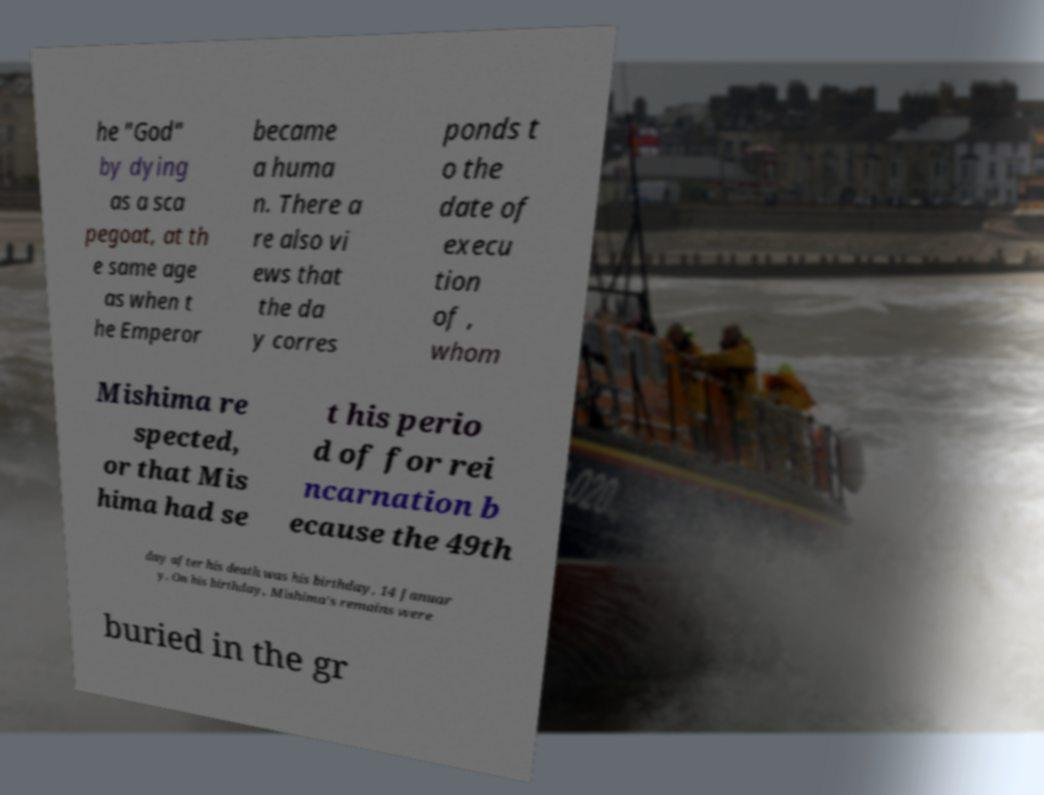There's text embedded in this image that I need extracted. Can you transcribe it verbatim? he "God" by dying as a sca pegoat, at th e same age as when t he Emperor became a huma n. There a re also vi ews that the da y corres ponds t o the date of execu tion of , whom Mishima re spected, or that Mis hima had se t his perio d of for rei ncarnation b ecause the 49th day after his death was his birthday, 14 Januar y. On his birthday, Mishima's remains were buried in the gr 